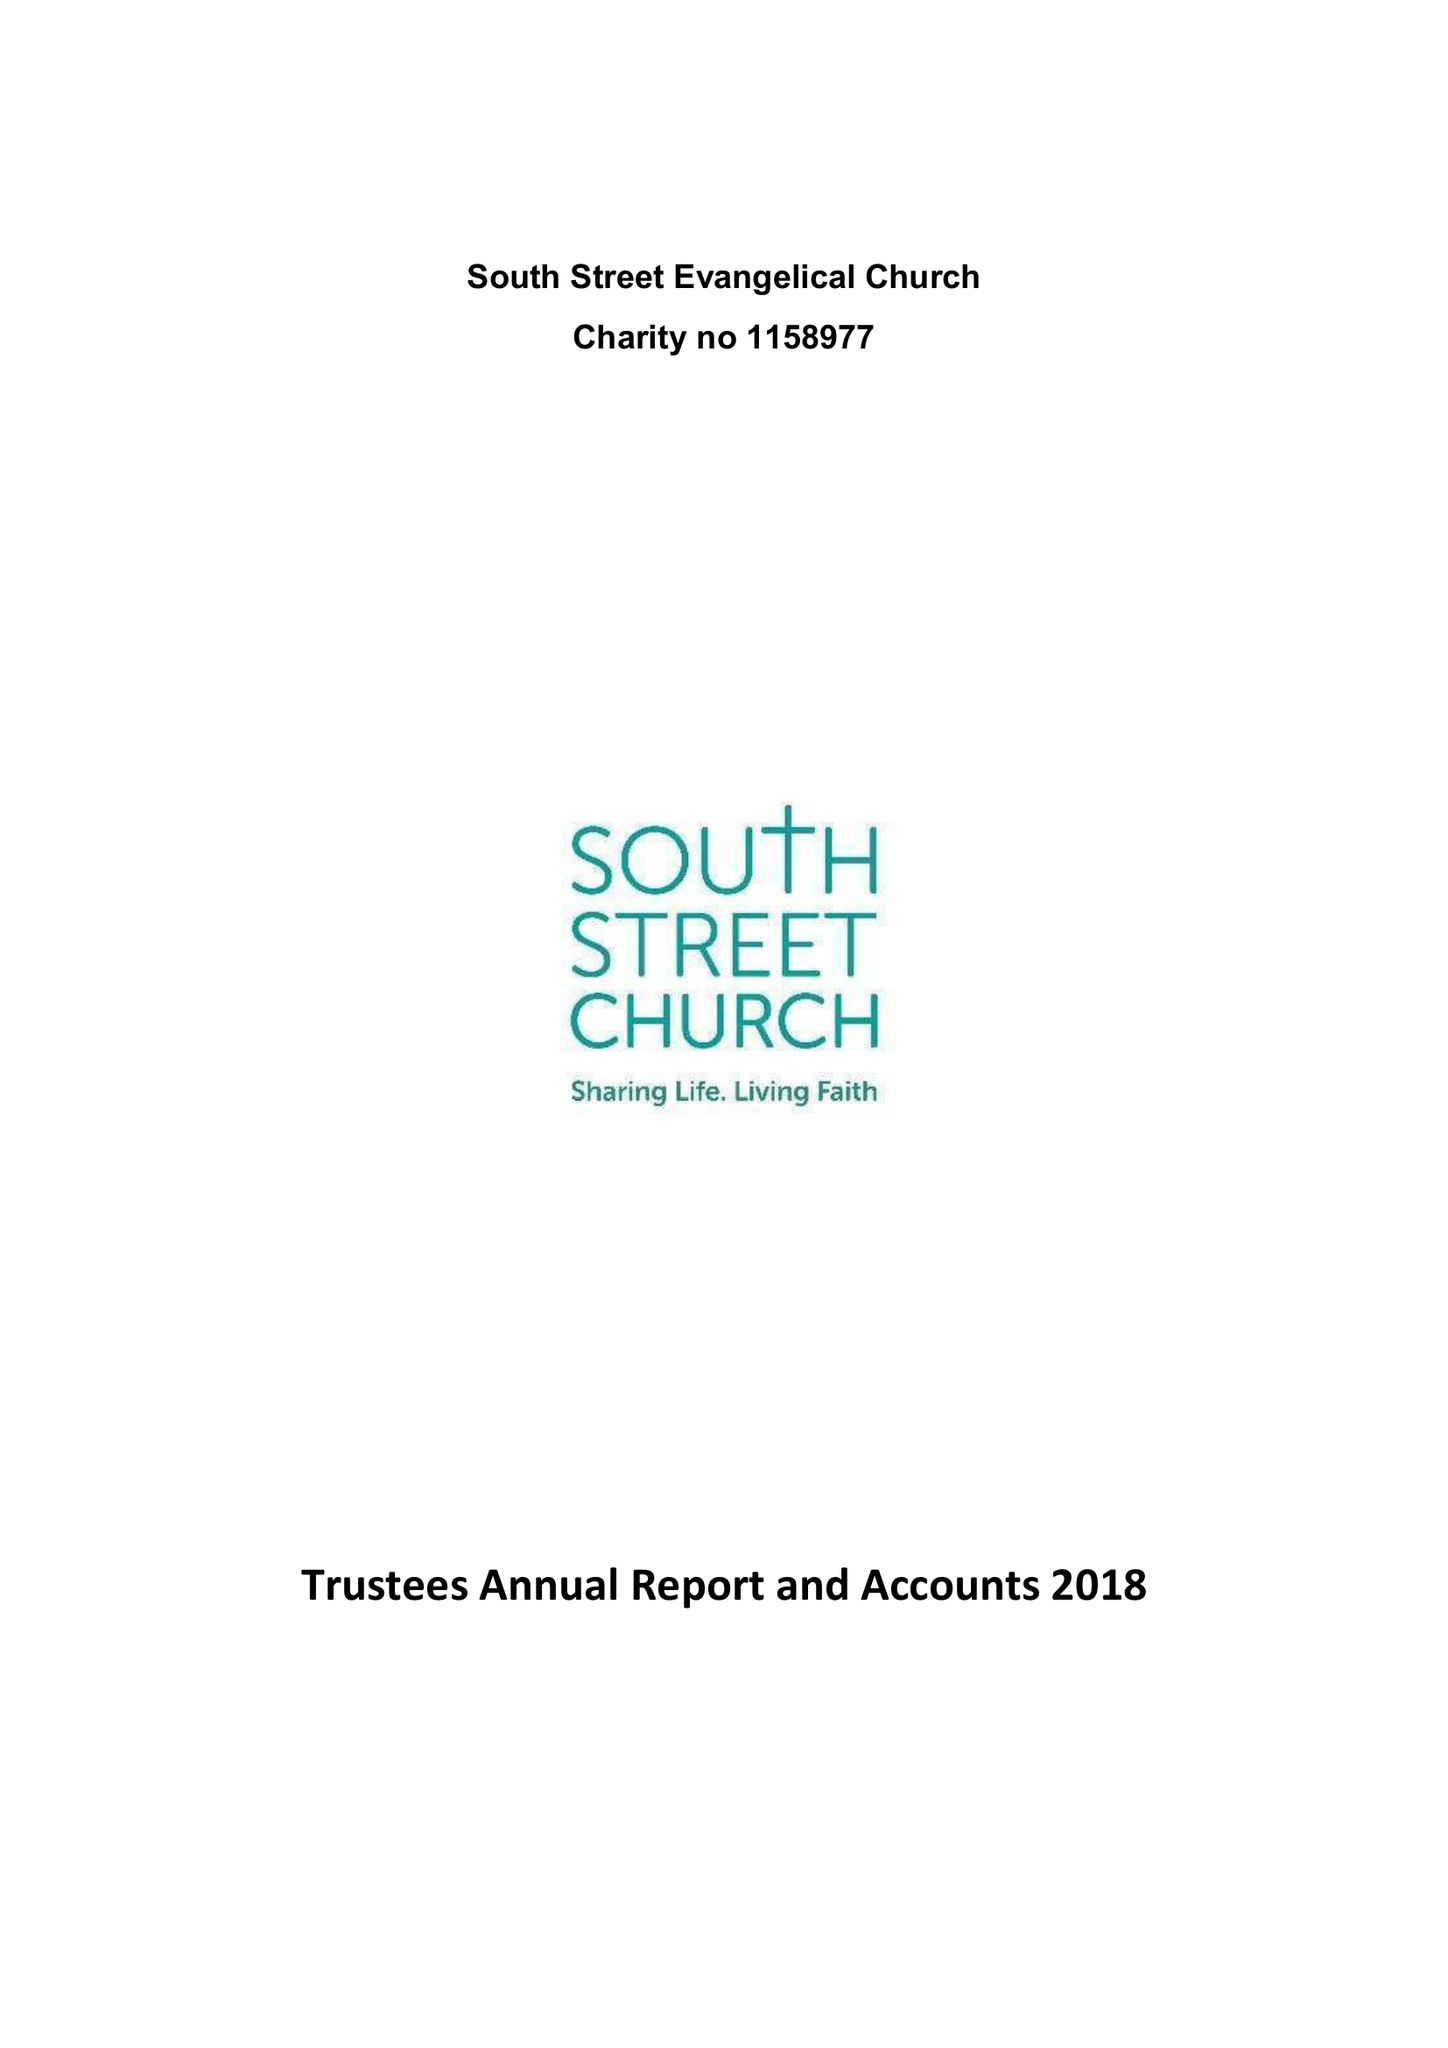What is the value for the charity_name?
Answer the question using a single word or phrase. South Street Evangelical Church 